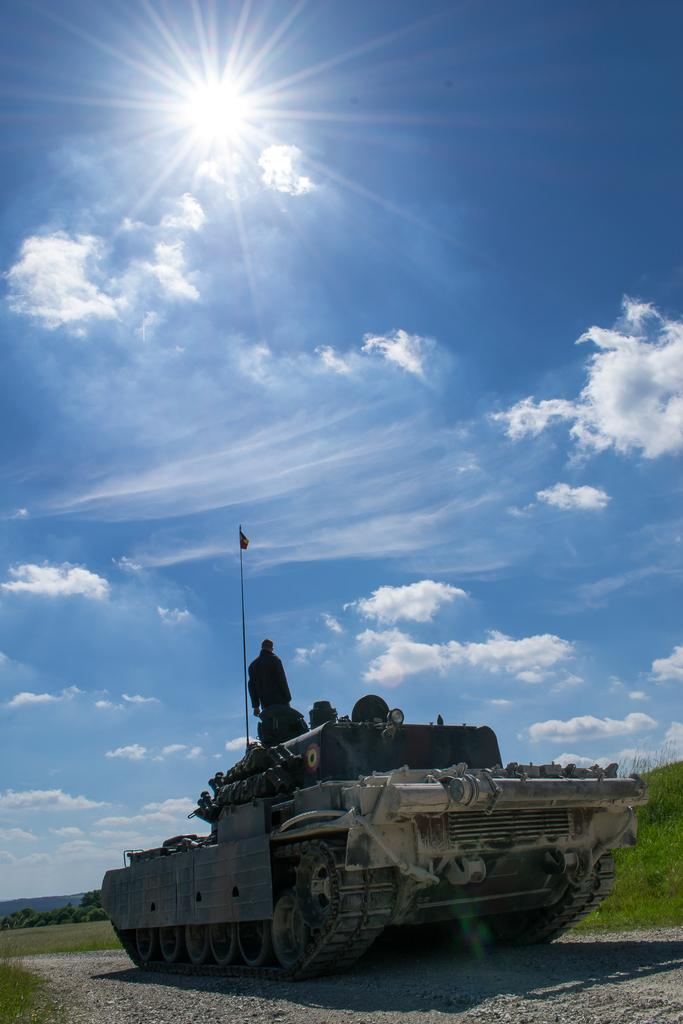What is the main subject of the image? The main subject of the image is a tank. What can be seen in the image besides the tank? There is a shadow, grass, a flag, and clouds in the background of the image. The sun and sky are also visible in the background. What type of bottle is being used to water the grass in the image? There is no bottle present in the image, and the grass does not appear to be watered. 